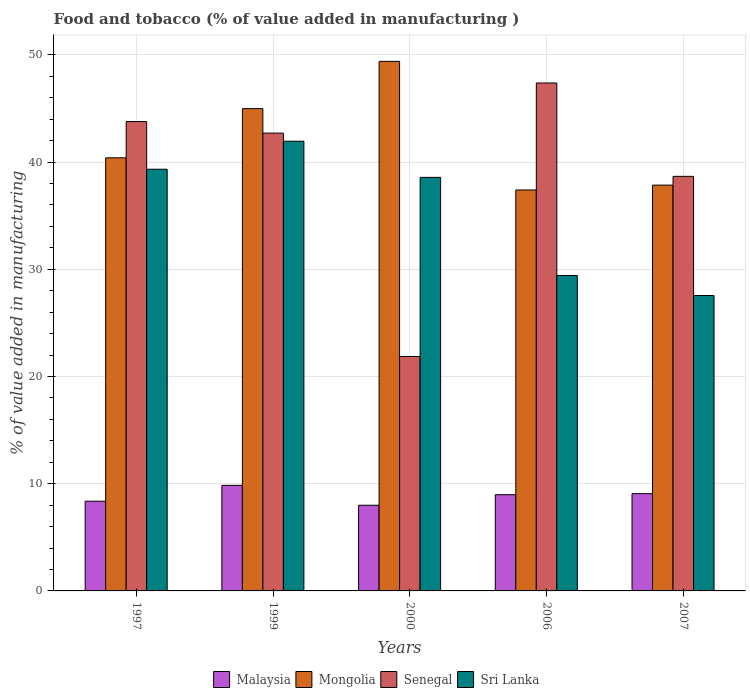Are the number of bars on each tick of the X-axis equal?
Give a very brief answer. Yes. How many bars are there on the 2nd tick from the left?
Give a very brief answer. 4. How many bars are there on the 2nd tick from the right?
Keep it short and to the point. 4. What is the label of the 1st group of bars from the left?
Your response must be concise. 1997. What is the value added in manufacturing food and tobacco in Malaysia in 1997?
Provide a short and direct response. 8.37. Across all years, what is the maximum value added in manufacturing food and tobacco in Mongolia?
Ensure brevity in your answer.  49.39. Across all years, what is the minimum value added in manufacturing food and tobacco in Senegal?
Provide a succinct answer. 21.87. In which year was the value added in manufacturing food and tobacco in Mongolia maximum?
Your response must be concise. 2000. In which year was the value added in manufacturing food and tobacco in Mongolia minimum?
Offer a very short reply. 2006. What is the total value added in manufacturing food and tobacco in Senegal in the graph?
Give a very brief answer. 194.38. What is the difference between the value added in manufacturing food and tobacco in Sri Lanka in 1997 and that in 2006?
Provide a succinct answer. 9.91. What is the difference between the value added in manufacturing food and tobacco in Senegal in 2006 and the value added in manufacturing food and tobacco in Sri Lanka in 1999?
Keep it short and to the point. 5.43. What is the average value added in manufacturing food and tobacco in Senegal per year?
Ensure brevity in your answer.  38.88. In the year 2006, what is the difference between the value added in manufacturing food and tobacco in Malaysia and value added in manufacturing food and tobacco in Sri Lanka?
Provide a succinct answer. -20.44. In how many years, is the value added in manufacturing food and tobacco in Sri Lanka greater than 28 %?
Your response must be concise. 4. What is the ratio of the value added in manufacturing food and tobacco in Sri Lanka in 1997 to that in 2006?
Keep it short and to the point. 1.34. Is the value added in manufacturing food and tobacco in Sri Lanka in 1999 less than that in 2007?
Ensure brevity in your answer.  No. What is the difference between the highest and the second highest value added in manufacturing food and tobacco in Senegal?
Make the answer very short. 3.6. What is the difference between the highest and the lowest value added in manufacturing food and tobacco in Sri Lanka?
Ensure brevity in your answer.  14.39. Is it the case that in every year, the sum of the value added in manufacturing food and tobacco in Mongolia and value added in manufacturing food and tobacco in Malaysia is greater than the sum of value added in manufacturing food and tobacco in Sri Lanka and value added in manufacturing food and tobacco in Senegal?
Give a very brief answer. No. What does the 1st bar from the left in 1999 represents?
Offer a very short reply. Malaysia. What does the 2nd bar from the right in 1999 represents?
Your answer should be very brief. Senegal. Is it the case that in every year, the sum of the value added in manufacturing food and tobacco in Mongolia and value added in manufacturing food and tobacco in Senegal is greater than the value added in manufacturing food and tobacco in Malaysia?
Provide a short and direct response. Yes. How many bars are there?
Your answer should be compact. 20. Are all the bars in the graph horizontal?
Ensure brevity in your answer.  No. How many years are there in the graph?
Provide a short and direct response. 5. What is the difference between two consecutive major ticks on the Y-axis?
Your response must be concise. 10. Does the graph contain any zero values?
Keep it short and to the point. No. Where does the legend appear in the graph?
Provide a short and direct response. Bottom center. How many legend labels are there?
Your response must be concise. 4. How are the legend labels stacked?
Your answer should be very brief. Horizontal. What is the title of the graph?
Give a very brief answer. Food and tobacco (% of value added in manufacturing ). What is the label or title of the Y-axis?
Your answer should be compact. % of value added in manufacturing. What is the % of value added in manufacturing in Malaysia in 1997?
Your response must be concise. 8.37. What is the % of value added in manufacturing of Mongolia in 1997?
Ensure brevity in your answer.  40.4. What is the % of value added in manufacturing in Senegal in 1997?
Keep it short and to the point. 43.78. What is the % of value added in manufacturing of Sri Lanka in 1997?
Your answer should be compact. 39.33. What is the % of value added in manufacturing of Malaysia in 1999?
Provide a short and direct response. 9.84. What is the % of value added in manufacturing of Mongolia in 1999?
Give a very brief answer. 44.98. What is the % of value added in manufacturing in Senegal in 1999?
Your answer should be compact. 42.7. What is the % of value added in manufacturing in Sri Lanka in 1999?
Provide a succinct answer. 41.94. What is the % of value added in manufacturing in Malaysia in 2000?
Provide a short and direct response. 7.99. What is the % of value added in manufacturing in Mongolia in 2000?
Offer a very short reply. 49.39. What is the % of value added in manufacturing in Senegal in 2000?
Provide a short and direct response. 21.87. What is the % of value added in manufacturing of Sri Lanka in 2000?
Provide a short and direct response. 38.57. What is the % of value added in manufacturing in Malaysia in 2006?
Provide a short and direct response. 8.98. What is the % of value added in manufacturing of Mongolia in 2006?
Offer a terse response. 37.4. What is the % of value added in manufacturing of Senegal in 2006?
Offer a very short reply. 47.38. What is the % of value added in manufacturing of Sri Lanka in 2006?
Make the answer very short. 29.42. What is the % of value added in manufacturing of Malaysia in 2007?
Provide a short and direct response. 9.07. What is the % of value added in manufacturing of Mongolia in 2007?
Offer a terse response. 37.85. What is the % of value added in manufacturing in Senegal in 2007?
Provide a short and direct response. 38.67. What is the % of value added in manufacturing of Sri Lanka in 2007?
Make the answer very short. 27.55. Across all years, what is the maximum % of value added in manufacturing in Malaysia?
Keep it short and to the point. 9.84. Across all years, what is the maximum % of value added in manufacturing of Mongolia?
Offer a very short reply. 49.39. Across all years, what is the maximum % of value added in manufacturing in Senegal?
Offer a terse response. 47.38. Across all years, what is the maximum % of value added in manufacturing in Sri Lanka?
Make the answer very short. 41.94. Across all years, what is the minimum % of value added in manufacturing in Malaysia?
Your answer should be compact. 7.99. Across all years, what is the minimum % of value added in manufacturing of Mongolia?
Provide a succinct answer. 37.4. Across all years, what is the minimum % of value added in manufacturing of Senegal?
Your response must be concise. 21.87. Across all years, what is the minimum % of value added in manufacturing in Sri Lanka?
Ensure brevity in your answer.  27.55. What is the total % of value added in manufacturing of Malaysia in the graph?
Your response must be concise. 44.25. What is the total % of value added in manufacturing of Mongolia in the graph?
Your answer should be compact. 210.01. What is the total % of value added in manufacturing of Senegal in the graph?
Your response must be concise. 194.38. What is the total % of value added in manufacturing of Sri Lanka in the graph?
Make the answer very short. 176.82. What is the difference between the % of value added in manufacturing in Malaysia in 1997 and that in 1999?
Your answer should be compact. -1.48. What is the difference between the % of value added in manufacturing of Mongolia in 1997 and that in 1999?
Offer a terse response. -4.59. What is the difference between the % of value added in manufacturing in Senegal in 1997 and that in 1999?
Make the answer very short. 1.08. What is the difference between the % of value added in manufacturing of Sri Lanka in 1997 and that in 1999?
Your answer should be compact. -2.61. What is the difference between the % of value added in manufacturing of Malaysia in 1997 and that in 2000?
Provide a succinct answer. 0.38. What is the difference between the % of value added in manufacturing of Mongolia in 1997 and that in 2000?
Your answer should be compact. -9. What is the difference between the % of value added in manufacturing in Senegal in 1997 and that in 2000?
Your answer should be very brief. 21.91. What is the difference between the % of value added in manufacturing in Sri Lanka in 1997 and that in 2000?
Your answer should be very brief. 0.76. What is the difference between the % of value added in manufacturing of Malaysia in 1997 and that in 2006?
Keep it short and to the point. -0.61. What is the difference between the % of value added in manufacturing of Mongolia in 1997 and that in 2006?
Ensure brevity in your answer.  3. What is the difference between the % of value added in manufacturing of Senegal in 1997 and that in 2006?
Your response must be concise. -3.6. What is the difference between the % of value added in manufacturing of Sri Lanka in 1997 and that in 2006?
Give a very brief answer. 9.91. What is the difference between the % of value added in manufacturing of Malaysia in 1997 and that in 2007?
Your answer should be compact. -0.7. What is the difference between the % of value added in manufacturing of Mongolia in 1997 and that in 2007?
Your answer should be compact. 2.55. What is the difference between the % of value added in manufacturing of Senegal in 1997 and that in 2007?
Offer a terse response. 5.11. What is the difference between the % of value added in manufacturing in Sri Lanka in 1997 and that in 2007?
Offer a terse response. 11.78. What is the difference between the % of value added in manufacturing in Malaysia in 1999 and that in 2000?
Keep it short and to the point. 1.85. What is the difference between the % of value added in manufacturing of Mongolia in 1999 and that in 2000?
Provide a succinct answer. -4.41. What is the difference between the % of value added in manufacturing in Senegal in 1999 and that in 2000?
Offer a terse response. 20.83. What is the difference between the % of value added in manufacturing in Sri Lanka in 1999 and that in 2000?
Your answer should be compact. 3.37. What is the difference between the % of value added in manufacturing in Malaysia in 1999 and that in 2006?
Provide a succinct answer. 0.87. What is the difference between the % of value added in manufacturing in Mongolia in 1999 and that in 2006?
Your answer should be compact. 7.59. What is the difference between the % of value added in manufacturing in Senegal in 1999 and that in 2006?
Offer a very short reply. -4.68. What is the difference between the % of value added in manufacturing of Sri Lanka in 1999 and that in 2006?
Ensure brevity in your answer.  12.52. What is the difference between the % of value added in manufacturing in Malaysia in 1999 and that in 2007?
Ensure brevity in your answer.  0.77. What is the difference between the % of value added in manufacturing in Mongolia in 1999 and that in 2007?
Keep it short and to the point. 7.13. What is the difference between the % of value added in manufacturing in Senegal in 1999 and that in 2007?
Your answer should be compact. 4.03. What is the difference between the % of value added in manufacturing of Sri Lanka in 1999 and that in 2007?
Provide a succinct answer. 14.39. What is the difference between the % of value added in manufacturing in Malaysia in 2000 and that in 2006?
Your answer should be compact. -0.99. What is the difference between the % of value added in manufacturing in Mongolia in 2000 and that in 2006?
Offer a terse response. 12. What is the difference between the % of value added in manufacturing in Senegal in 2000 and that in 2006?
Ensure brevity in your answer.  -25.51. What is the difference between the % of value added in manufacturing of Sri Lanka in 2000 and that in 2006?
Offer a terse response. 9.15. What is the difference between the % of value added in manufacturing of Malaysia in 2000 and that in 2007?
Offer a terse response. -1.08. What is the difference between the % of value added in manufacturing in Mongolia in 2000 and that in 2007?
Your response must be concise. 11.54. What is the difference between the % of value added in manufacturing of Senegal in 2000 and that in 2007?
Give a very brief answer. -16.8. What is the difference between the % of value added in manufacturing of Sri Lanka in 2000 and that in 2007?
Your answer should be very brief. 11.02. What is the difference between the % of value added in manufacturing of Malaysia in 2006 and that in 2007?
Offer a very short reply. -0.1. What is the difference between the % of value added in manufacturing in Mongolia in 2006 and that in 2007?
Your answer should be very brief. -0.45. What is the difference between the % of value added in manufacturing in Senegal in 2006 and that in 2007?
Provide a short and direct response. 8.71. What is the difference between the % of value added in manufacturing in Sri Lanka in 2006 and that in 2007?
Ensure brevity in your answer.  1.87. What is the difference between the % of value added in manufacturing of Malaysia in 1997 and the % of value added in manufacturing of Mongolia in 1999?
Give a very brief answer. -36.62. What is the difference between the % of value added in manufacturing of Malaysia in 1997 and the % of value added in manufacturing of Senegal in 1999?
Your answer should be very brief. -34.33. What is the difference between the % of value added in manufacturing in Malaysia in 1997 and the % of value added in manufacturing in Sri Lanka in 1999?
Provide a succinct answer. -33.58. What is the difference between the % of value added in manufacturing of Mongolia in 1997 and the % of value added in manufacturing of Senegal in 1999?
Provide a succinct answer. -2.3. What is the difference between the % of value added in manufacturing in Mongolia in 1997 and the % of value added in manufacturing in Sri Lanka in 1999?
Offer a very short reply. -1.55. What is the difference between the % of value added in manufacturing of Senegal in 1997 and the % of value added in manufacturing of Sri Lanka in 1999?
Offer a terse response. 1.83. What is the difference between the % of value added in manufacturing of Malaysia in 1997 and the % of value added in manufacturing of Mongolia in 2000?
Your answer should be compact. -41.02. What is the difference between the % of value added in manufacturing in Malaysia in 1997 and the % of value added in manufacturing in Senegal in 2000?
Keep it short and to the point. -13.5. What is the difference between the % of value added in manufacturing in Malaysia in 1997 and the % of value added in manufacturing in Sri Lanka in 2000?
Offer a very short reply. -30.2. What is the difference between the % of value added in manufacturing in Mongolia in 1997 and the % of value added in manufacturing in Senegal in 2000?
Your answer should be compact. 18.53. What is the difference between the % of value added in manufacturing in Mongolia in 1997 and the % of value added in manufacturing in Sri Lanka in 2000?
Provide a short and direct response. 1.82. What is the difference between the % of value added in manufacturing of Senegal in 1997 and the % of value added in manufacturing of Sri Lanka in 2000?
Offer a very short reply. 5.21. What is the difference between the % of value added in manufacturing in Malaysia in 1997 and the % of value added in manufacturing in Mongolia in 2006?
Offer a very short reply. -29.03. What is the difference between the % of value added in manufacturing in Malaysia in 1997 and the % of value added in manufacturing in Senegal in 2006?
Make the answer very short. -39.01. What is the difference between the % of value added in manufacturing in Malaysia in 1997 and the % of value added in manufacturing in Sri Lanka in 2006?
Your answer should be compact. -21.05. What is the difference between the % of value added in manufacturing of Mongolia in 1997 and the % of value added in manufacturing of Senegal in 2006?
Your answer should be very brief. -6.98. What is the difference between the % of value added in manufacturing in Mongolia in 1997 and the % of value added in manufacturing in Sri Lanka in 2006?
Provide a succinct answer. 10.98. What is the difference between the % of value added in manufacturing in Senegal in 1997 and the % of value added in manufacturing in Sri Lanka in 2006?
Your answer should be compact. 14.36. What is the difference between the % of value added in manufacturing of Malaysia in 1997 and the % of value added in manufacturing of Mongolia in 2007?
Keep it short and to the point. -29.48. What is the difference between the % of value added in manufacturing of Malaysia in 1997 and the % of value added in manufacturing of Senegal in 2007?
Your response must be concise. -30.3. What is the difference between the % of value added in manufacturing of Malaysia in 1997 and the % of value added in manufacturing of Sri Lanka in 2007?
Ensure brevity in your answer.  -19.18. What is the difference between the % of value added in manufacturing in Mongolia in 1997 and the % of value added in manufacturing in Senegal in 2007?
Your answer should be very brief. 1.73. What is the difference between the % of value added in manufacturing in Mongolia in 1997 and the % of value added in manufacturing in Sri Lanka in 2007?
Your answer should be compact. 12.84. What is the difference between the % of value added in manufacturing in Senegal in 1997 and the % of value added in manufacturing in Sri Lanka in 2007?
Keep it short and to the point. 16.22. What is the difference between the % of value added in manufacturing of Malaysia in 1999 and the % of value added in manufacturing of Mongolia in 2000?
Keep it short and to the point. -39.55. What is the difference between the % of value added in manufacturing in Malaysia in 1999 and the % of value added in manufacturing in Senegal in 2000?
Your response must be concise. -12.02. What is the difference between the % of value added in manufacturing in Malaysia in 1999 and the % of value added in manufacturing in Sri Lanka in 2000?
Your answer should be compact. -28.73. What is the difference between the % of value added in manufacturing of Mongolia in 1999 and the % of value added in manufacturing of Senegal in 2000?
Give a very brief answer. 23.12. What is the difference between the % of value added in manufacturing in Mongolia in 1999 and the % of value added in manufacturing in Sri Lanka in 2000?
Your response must be concise. 6.41. What is the difference between the % of value added in manufacturing in Senegal in 1999 and the % of value added in manufacturing in Sri Lanka in 2000?
Your response must be concise. 4.13. What is the difference between the % of value added in manufacturing of Malaysia in 1999 and the % of value added in manufacturing of Mongolia in 2006?
Your response must be concise. -27.55. What is the difference between the % of value added in manufacturing of Malaysia in 1999 and the % of value added in manufacturing of Senegal in 2006?
Make the answer very short. -37.53. What is the difference between the % of value added in manufacturing in Malaysia in 1999 and the % of value added in manufacturing in Sri Lanka in 2006?
Keep it short and to the point. -19.57. What is the difference between the % of value added in manufacturing of Mongolia in 1999 and the % of value added in manufacturing of Senegal in 2006?
Give a very brief answer. -2.39. What is the difference between the % of value added in manufacturing of Mongolia in 1999 and the % of value added in manufacturing of Sri Lanka in 2006?
Give a very brief answer. 15.56. What is the difference between the % of value added in manufacturing in Senegal in 1999 and the % of value added in manufacturing in Sri Lanka in 2006?
Offer a very short reply. 13.28. What is the difference between the % of value added in manufacturing of Malaysia in 1999 and the % of value added in manufacturing of Mongolia in 2007?
Make the answer very short. -28. What is the difference between the % of value added in manufacturing in Malaysia in 1999 and the % of value added in manufacturing in Senegal in 2007?
Make the answer very short. -28.82. What is the difference between the % of value added in manufacturing in Malaysia in 1999 and the % of value added in manufacturing in Sri Lanka in 2007?
Make the answer very short. -17.71. What is the difference between the % of value added in manufacturing of Mongolia in 1999 and the % of value added in manufacturing of Senegal in 2007?
Your response must be concise. 6.32. What is the difference between the % of value added in manufacturing of Mongolia in 1999 and the % of value added in manufacturing of Sri Lanka in 2007?
Your answer should be very brief. 17.43. What is the difference between the % of value added in manufacturing in Senegal in 1999 and the % of value added in manufacturing in Sri Lanka in 2007?
Your response must be concise. 15.15. What is the difference between the % of value added in manufacturing of Malaysia in 2000 and the % of value added in manufacturing of Mongolia in 2006?
Keep it short and to the point. -29.4. What is the difference between the % of value added in manufacturing of Malaysia in 2000 and the % of value added in manufacturing of Senegal in 2006?
Offer a terse response. -39.38. What is the difference between the % of value added in manufacturing of Malaysia in 2000 and the % of value added in manufacturing of Sri Lanka in 2006?
Provide a succinct answer. -21.43. What is the difference between the % of value added in manufacturing of Mongolia in 2000 and the % of value added in manufacturing of Senegal in 2006?
Your response must be concise. 2.02. What is the difference between the % of value added in manufacturing of Mongolia in 2000 and the % of value added in manufacturing of Sri Lanka in 2006?
Your answer should be compact. 19.97. What is the difference between the % of value added in manufacturing in Senegal in 2000 and the % of value added in manufacturing in Sri Lanka in 2006?
Your answer should be very brief. -7.55. What is the difference between the % of value added in manufacturing of Malaysia in 2000 and the % of value added in manufacturing of Mongolia in 2007?
Ensure brevity in your answer.  -29.86. What is the difference between the % of value added in manufacturing of Malaysia in 2000 and the % of value added in manufacturing of Senegal in 2007?
Make the answer very short. -30.67. What is the difference between the % of value added in manufacturing in Malaysia in 2000 and the % of value added in manufacturing in Sri Lanka in 2007?
Your answer should be very brief. -19.56. What is the difference between the % of value added in manufacturing in Mongolia in 2000 and the % of value added in manufacturing in Senegal in 2007?
Your answer should be compact. 10.73. What is the difference between the % of value added in manufacturing in Mongolia in 2000 and the % of value added in manufacturing in Sri Lanka in 2007?
Your answer should be very brief. 21.84. What is the difference between the % of value added in manufacturing of Senegal in 2000 and the % of value added in manufacturing of Sri Lanka in 2007?
Provide a succinct answer. -5.69. What is the difference between the % of value added in manufacturing of Malaysia in 2006 and the % of value added in manufacturing of Mongolia in 2007?
Provide a short and direct response. -28.87. What is the difference between the % of value added in manufacturing of Malaysia in 2006 and the % of value added in manufacturing of Senegal in 2007?
Your answer should be compact. -29.69. What is the difference between the % of value added in manufacturing of Malaysia in 2006 and the % of value added in manufacturing of Sri Lanka in 2007?
Your response must be concise. -18.58. What is the difference between the % of value added in manufacturing of Mongolia in 2006 and the % of value added in manufacturing of Senegal in 2007?
Your answer should be very brief. -1.27. What is the difference between the % of value added in manufacturing in Mongolia in 2006 and the % of value added in manufacturing in Sri Lanka in 2007?
Offer a very short reply. 9.84. What is the difference between the % of value added in manufacturing in Senegal in 2006 and the % of value added in manufacturing in Sri Lanka in 2007?
Offer a terse response. 19.82. What is the average % of value added in manufacturing in Malaysia per year?
Your response must be concise. 8.85. What is the average % of value added in manufacturing of Mongolia per year?
Provide a succinct answer. 42. What is the average % of value added in manufacturing of Senegal per year?
Make the answer very short. 38.88. What is the average % of value added in manufacturing of Sri Lanka per year?
Your answer should be compact. 35.36. In the year 1997, what is the difference between the % of value added in manufacturing of Malaysia and % of value added in manufacturing of Mongolia?
Ensure brevity in your answer.  -32.03. In the year 1997, what is the difference between the % of value added in manufacturing in Malaysia and % of value added in manufacturing in Senegal?
Offer a very short reply. -35.41. In the year 1997, what is the difference between the % of value added in manufacturing in Malaysia and % of value added in manufacturing in Sri Lanka?
Ensure brevity in your answer.  -30.96. In the year 1997, what is the difference between the % of value added in manufacturing of Mongolia and % of value added in manufacturing of Senegal?
Provide a short and direct response. -3.38. In the year 1997, what is the difference between the % of value added in manufacturing of Mongolia and % of value added in manufacturing of Sri Lanka?
Make the answer very short. 1.07. In the year 1997, what is the difference between the % of value added in manufacturing of Senegal and % of value added in manufacturing of Sri Lanka?
Your answer should be very brief. 4.45. In the year 1999, what is the difference between the % of value added in manufacturing of Malaysia and % of value added in manufacturing of Mongolia?
Offer a terse response. -35.14. In the year 1999, what is the difference between the % of value added in manufacturing of Malaysia and % of value added in manufacturing of Senegal?
Offer a terse response. -32.85. In the year 1999, what is the difference between the % of value added in manufacturing of Malaysia and % of value added in manufacturing of Sri Lanka?
Offer a very short reply. -32.1. In the year 1999, what is the difference between the % of value added in manufacturing of Mongolia and % of value added in manufacturing of Senegal?
Keep it short and to the point. 2.28. In the year 1999, what is the difference between the % of value added in manufacturing of Mongolia and % of value added in manufacturing of Sri Lanka?
Provide a succinct answer. 3.04. In the year 1999, what is the difference between the % of value added in manufacturing of Senegal and % of value added in manufacturing of Sri Lanka?
Offer a very short reply. 0.76. In the year 2000, what is the difference between the % of value added in manufacturing of Malaysia and % of value added in manufacturing of Mongolia?
Your answer should be very brief. -41.4. In the year 2000, what is the difference between the % of value added in manufacturing in Malaysia and % of value added in manufacturing in Senegal?
Keep it short and to the point. -13.87. In the year 2000, what is the difference between the % of value added in manufacturing of Malaysia and % of value added in manufacturing of Sri Lanka?
Provide a succinct answer. -30.58. In the year 2000, what is the difference between the % of value added in manufacturing in Mongolia and % of value added in manufacturing in Senegal?
Your answer should be very brief. 27.53. In the year 2000, what is the difference between the % of value added in manufacturing of Mongolia and % of value added in manufacturing of Sri Lanka?
Keep it short and to the point. 10.82. In the year 2000, what is the difference between the % of value added in manufacturing of Senegal and % of value added in manufacturing of Sri Lanka?
Keep it short and to the point. -16.7. In the year 2006, what is the difference between the % of value added in manufacturing in Malaysia and % of value added in manufacturing in Mongolia?
Give a very brief answer. -28.42. In the year 2006, what is the difference between the % of value added in manufacturing in Malaysia and % of value added in manufacturing in Senegal?
Your response must be concise. -38.4. In the year 2006, what is the difference between the % of value added in manufacturing in Malaysia and % of value added in manufacturing in Sri Lanka?
Make the answer very short. -20.44. In the year 2006, what is the difference between the % of value added in manufacturing of Mongolia and % of value added in manufacturing of Senegal?
Keep it short and to the point. -9.98. In the year 2006, what is the difference between the % of value added in manufacturing of Mongolia and % of value added in manufacturing of Sri Lanka?
Your answer should be very brief. 7.98. In the year 2006, what is the difference between the % of value added in manufacturing in Senegal and % of value added in manufacturing in Sri Lanka?
Your answer should be compact. 17.96. In the year 2007, what is the difference between the % of value added in manufacturing of Malaysia and % of value added in manufacturing of Mongolia?
Make the answer very short. -28.78. In the year 2007, what is the difference between the % of value added in manufacturing of Malaysia and % of value added in manufacturing of Senegal?
Provide a short and direct response. -29.59. In the year 2007, what is the difference between the % of value added in manufacturing in Malaysia and % of value added in manufacturing in Sri Lanka?
Your answer should be very brief. -18.48. In the year 2007, what is the difference between the % of value added in manufacturing in Mongolia and % of value added in manufacturing in Senegal?
Your response must be concise. -0.82. In the year 2007, what is the difference between the % of value added in manufacturing of Mongolia and % of value added in manufacturing of Sri Lanka?
Give a very brief answer. 10.3. In the year 2007, what is the difference between the % of value added in manufacturing in Senegal and % of value added in manufacturing in Sri Lanka?
Your answer should be very brief. 11.11. What is the ratio of the % of value added in manufacturing of Mongolia in 1997 to that in 1999?
Give a very brief answer. 0.9. What is the ratio of the % of value added in manufacturing in Senegal in 1997 to that in 1999?
Provide a short and direct response. 1.03. What is the ratio of the % of value added in manufacturing of Sri Lanka in 1997 to that in 1999?
Make the answer very short. 0.94. What is the ratio of the % of value added in manufacturing of Malaysia in 1997 to that in 2000?
Your answer should be compact. 1.05. What is the ratio of the % of value added in manufacturing in Mongolia in 1997 to that in 2000?
Offer a very short reply. 0.82. What is the ratio of the % of value added in manufacturing in Senegal in 1997 to that in 2000?
Your response must be concise. 2. What is the ratio of the % of value added in manufacturing in Sri Lanka in 1997 to that in 2000?
Your answer should be very brief. 1.02. What is the ratio of the % of value added in manufacturing in Malaysia in 1997 to that in 2006?
Provide a succinct answer. 0.93. What is the ratio of the % of value added in manufacturing of Mongolia in 1997 to that in 2006?
Your answer should be very brief. 1.08. What is the ratio of the % of value added in manufacturing of Senegal in 1997 to that in 2006?
Ensure brevity in your answer.  0.92. What is the ratio of the % of value added in manufacturing in Sri Lanka in 1997 to that in 2006?
Ensure brevity in your answer.  1.34. What is the ratio of the % of value added in manufacturing in Malaysia in 1997 to that in 2007?
Give a very brief answer. 0.92. What is the ratio of the % of value added in manufacturing of Mongolia in 1997 to that in 2007?
Give a very brief answer. 1.07. What is the ratio of the % of value added in manufacturing in Senegal in 1997 to that in 2007?
Give a very brief answer. 1.13. What is the ratio of the % of value added in manufacturing in Sri Lanka in 1997 to that in 2007?
Provide a succinct answer. 1.43. What is the ratio of the % of value added in manufacturing of Malaysia in 1999 to that in 2000?
Your answer should be compact. 1.23. What is the ratio of the % of value added in manufacturing in Mongolia in 1999 to that in 2000?
Offer a terse response. 0.91. What is the ratio of the % of value added in manufacturing of Senegal in 1999 to that in 2000?
Keep it short and to the point. 1.95. What is the ratio of the % of value added in manufacturing in Sri Lanka in 1999 to that in 2000?
Offer a very short reply. 1.09. What is the ratio of the % of value added in manufacturing in Malaysia in 1999 to that in 2006?
Your answer should be compact. 1.1. What is the ratio of the % of value added in manufacturing of Mongolia in 1999 to that in 2006?
Offer a very short reply. 1.2. What is the ratio of the % of value added in manufacturing in Senegal in 1999 to that in 2006?
Your response must be concise. 0.9. What is the ratio of the % of value added in manufacturing of Sri Lanka in 1999 to that in 2006?
Your response must be concise. 1.43. What is the ratio of the % of value added in manufacturing in Malaysia in 1999 to that in 2007?
Offer a very short reply. 1.09. What is the ratio of the % of value added in manufacturing in Mongolia in 1999 to that in 2007?
Your response must be concise. 1.19. What is the ratio of the % of value added in manufacturing in Senegal in 1999 to that in 2007?
Provide a short and direct response. 1.1. What is the ratio of the % of value added in manufacturing of Sri Lanka in 1999 to that in 2007?
Your answer should be very brief. 1.52. What is the ratio of the % of value added in manufacturing in Malaysia in 2000 to that in 2006?
Your response must be concise. 0.89. What is the ratio of the % of value added in manufacturing in Mongolia in 2000 to that in 2006?
Offer a very short reply. 1.32. What is the ratio of the % of value added in manufacturing in Senegal in 2000 to that in 2006?
Give a very brief answer. 0.46. What is the ratio of the % of value added in manufacturing in Sri Lanka in 2000 to that in 2006?
Keep it short and to the point. 1.31. What is the ratio of the % of value added in manufacturing of Malaysia in 2000 to that in 2007?
Make the answer very short. 0.88. What is the ratio of the % of value added in manufacturing in Mongolia in 2000 to that in 2007?
Ensure brevity in your answer.  1.3. What is the ratio of the % of value added in manufacturing of Senegal in 2000 to that in 2007?
Provide a short and direct response. 0.57. What is the ratio of the % of value added in manufacturing in Sri Lanka in 2000 to that in 2007?
Give a very brief answer. 1.4. What is the ratio of the % of value added in manufacturing in Senegal in 2006 to that in 2007?
Keep it short and to the point. 1.23. What is the ratio of the % of value added in manufacturing of Sri Lanka in 2006 to that in 2007?
Offer a very short reply. 1.07. What is the difference between the highest and the second highest % of value added in manufacturing in Malaysia?
Ensure brevity in your answer.  0.77. What is the difference between the highest and the second highest % of value added in manufacturing of Mongolia?
Provide a short and direct response. 4.41. What is the difference between the highest and the second highest % of value added in manufacturing in Senegal?
Make the answer very short. 3.6. What is the difference between the highest and the second highest % of value added in manufacturing in Sri Lanka?
Provide a succinct answer. 2.61. What is the difference between the highest and the lowest % of value added in manufacturing in Malaysia?
Provide a succinct answer. 1.85. What is the difference between the highest and the lowest % of value added in manufacturing in Mongolia?
Give a very brief answer. 12. What is the difference between the highest and the lowest % of value added in manufacturing in Senegal?
Offer a very short reply. 25.51. What is the difference between the highest and the lowest % of value added in manufacturing in Sri Lanka?
Your response must be concise. 14.39. 